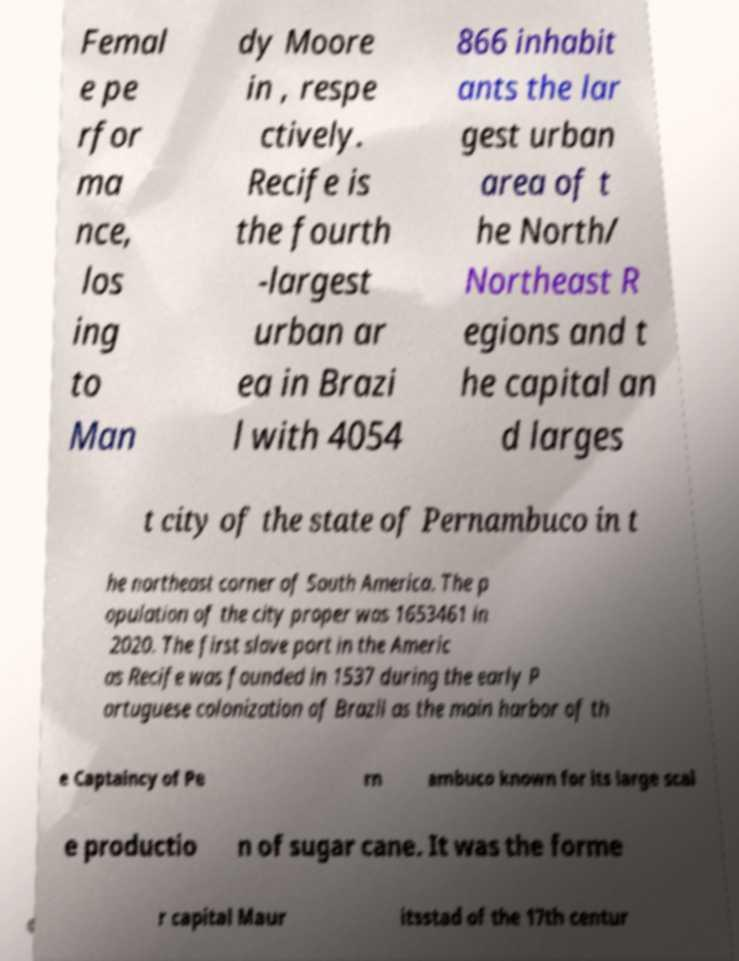Could you extract and type out the text from this image? Femal e pe rfor ma nce, los ing to Man dy Moore in , respe ctively. Recife is the fourth -largest urban ar ea in Brazi l with 4054 866 inhabit ants the lar gest urban area of t he North/ Northeast R egions and t he capital an d larges t city of the state of Pernambuco in t he northeast corner of South America. The p opulation of the city proper was 1653461 in 2020. The first slave port in the Americ as Recife was founded in 1537 during the early P ortuguese colonization of Brazil as the main harbor of th e Captaincy of Pe rn ambuco known for its large scal e productio n of sugar cane. It was the forme r capital Maur itsstad of the 17th centur 